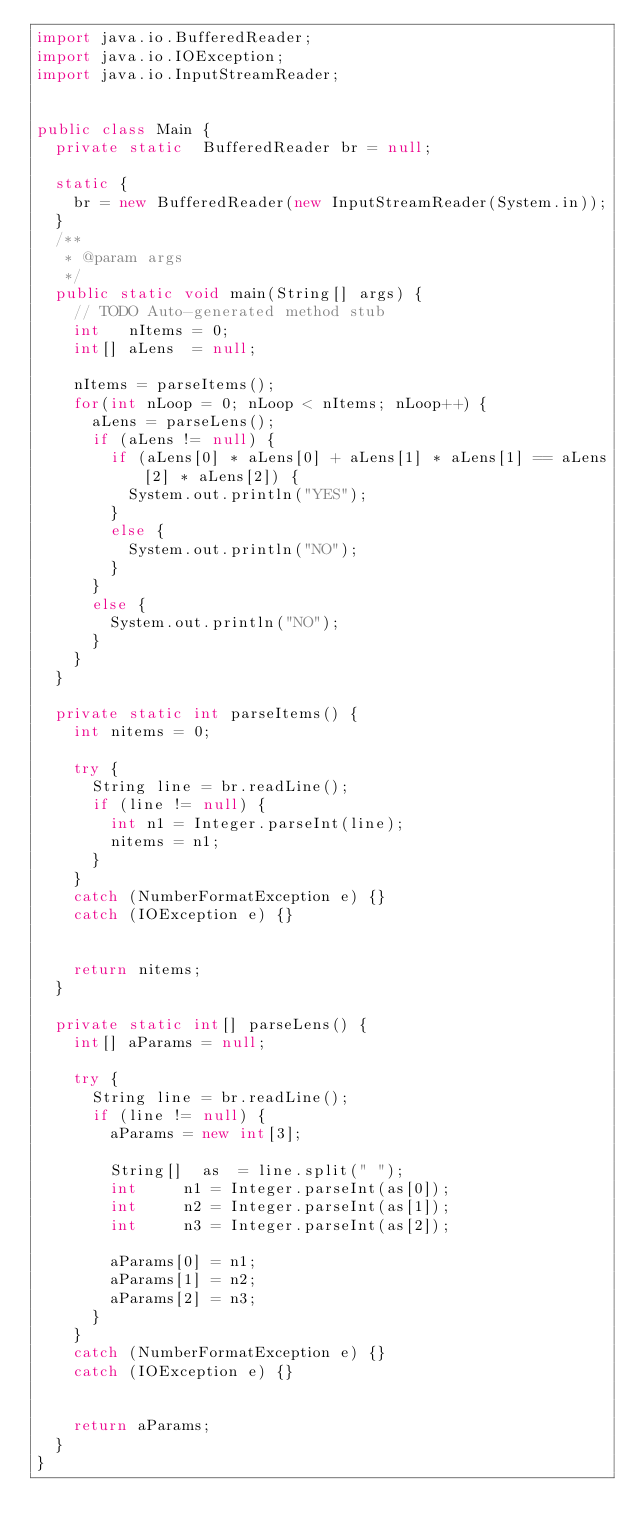Convert code to text. <code><loc_0><loc_0><loc_500><loc_500><_Java_>import java.io.BufferedReader;
import java.io.IOException;
import java.io.InputStreamReader;


public class Main {
	private	static	BufferedReader br = null;

	static {
		br = new BufferedReader(new InputStreamReader(System.in));
	}
	/**
	 * @param args
	 */
	public static void main(String[] args) {
		// TODO Auto-generated method stub
		int		nItems = 0;
		int[]	aLens  = null;

		nItems = parseItems();
		for(int nLoop = 0; nLoop < nItems; nLoop++) {
			aLens = parseLens();
			if (aLens != null) {
				if (aLens[0] * aLens[0] + aLens[1] * aLens[1] == aLens[2] * aLens[2]) {
					System.out.println("YES");
				}
				else {
					System.out.println("NO");
				}
			}
			else {
				System.out.println("NO");
			}
		}
	}

	private static int parseItems() {
		int nitems = 0;

		try {
			String line = br.readLine();
			if (line != null) {
				int	n1 = Integer.parseInt(line);
				nitems = n1;
			}
		}
		catch (NumberFormatException e) {}
		catch (IOException e) {}
		

		return nitems;
	}

	private static int[] parseLens() {
		int[] aParams = null;

		try {
			String line = br.readLine();
			if (line != null) {
				aParams = new int[3];

				String[]	as  = line.split(" ");
				int			n1 = Integer.parseInt(as[0]);
				int			n2 = Integer.parseInt(as[1]);
				int			n3 = Integer.parseInt(as[2]);

				aParams[0] = n1;
				aParams[1] = n2;
				aParams[2] = n3;
			}
		}
		catch (NumberFormatException e) {}
		catch (IOException e) {}
		

		return aParams;
	}
}</code> 